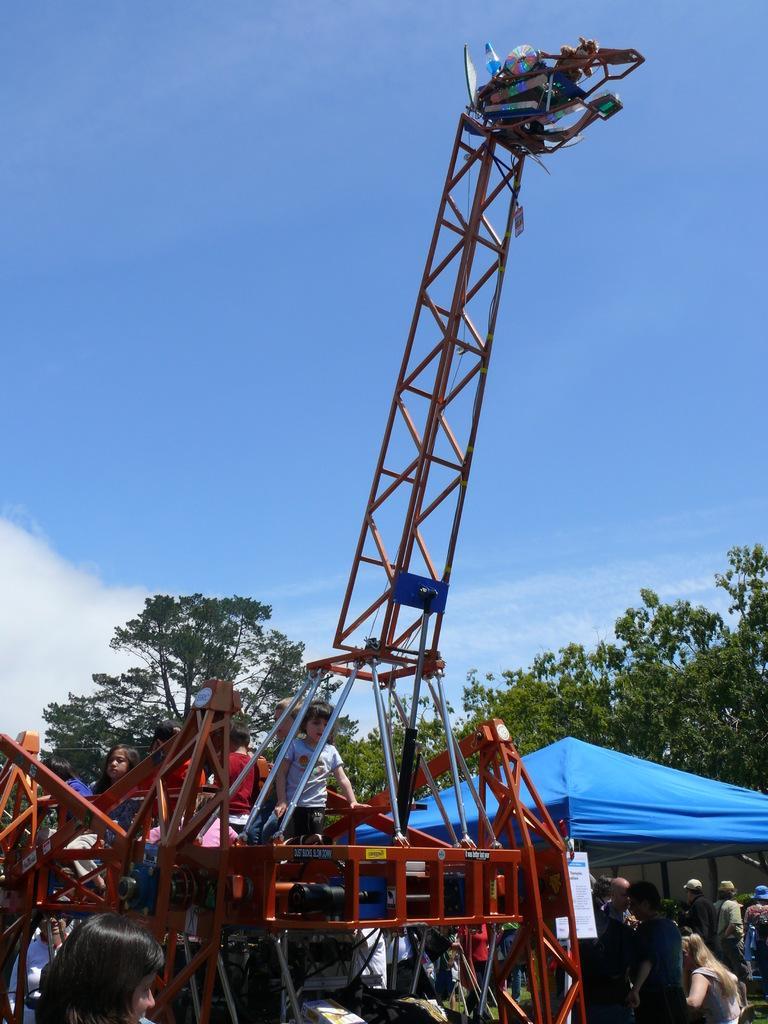In one or two sentences, can you explain what this image depicts? As we can see in the image there is a clear sky and there is a crane in front in which two kids are sitting and behind the crane there are lot of trees and in front of the trees there is a blue colour tent and below it people are standing on the ground. 